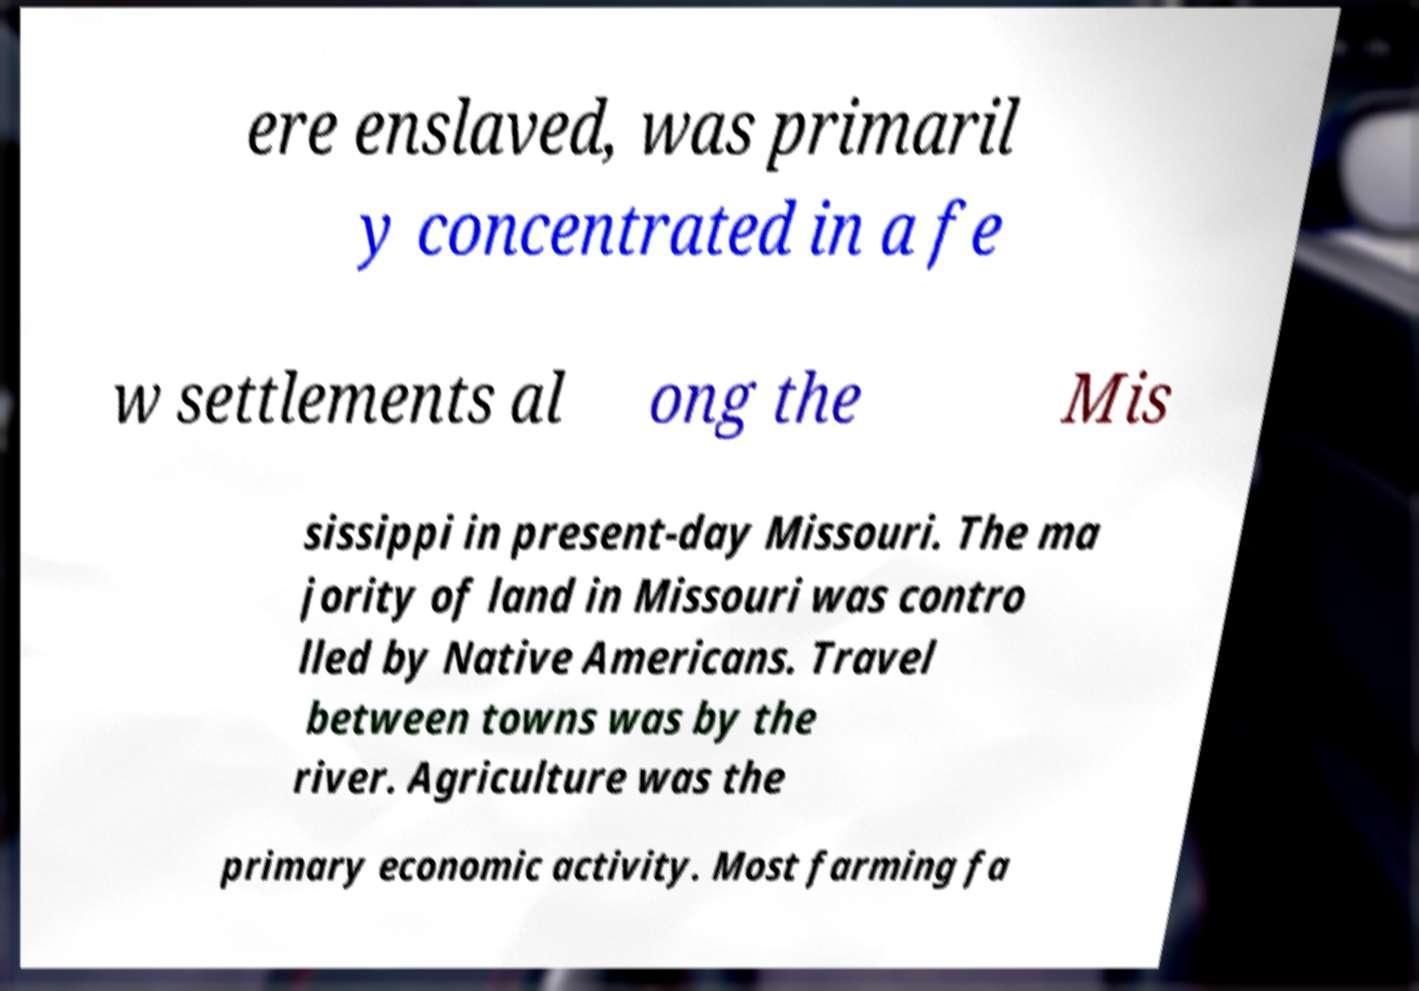Can you accurately transcribe the text from the provided image for me? ere enslaved, was primaril y concentrated in a fe w settlements al ong the Mis sissippi in present-day Missouri. The ma jority of land in Missouri was contro lled by Native Americans. Travel between towns was by the river. Agriculture was the primary economic activity. Most farming fa 